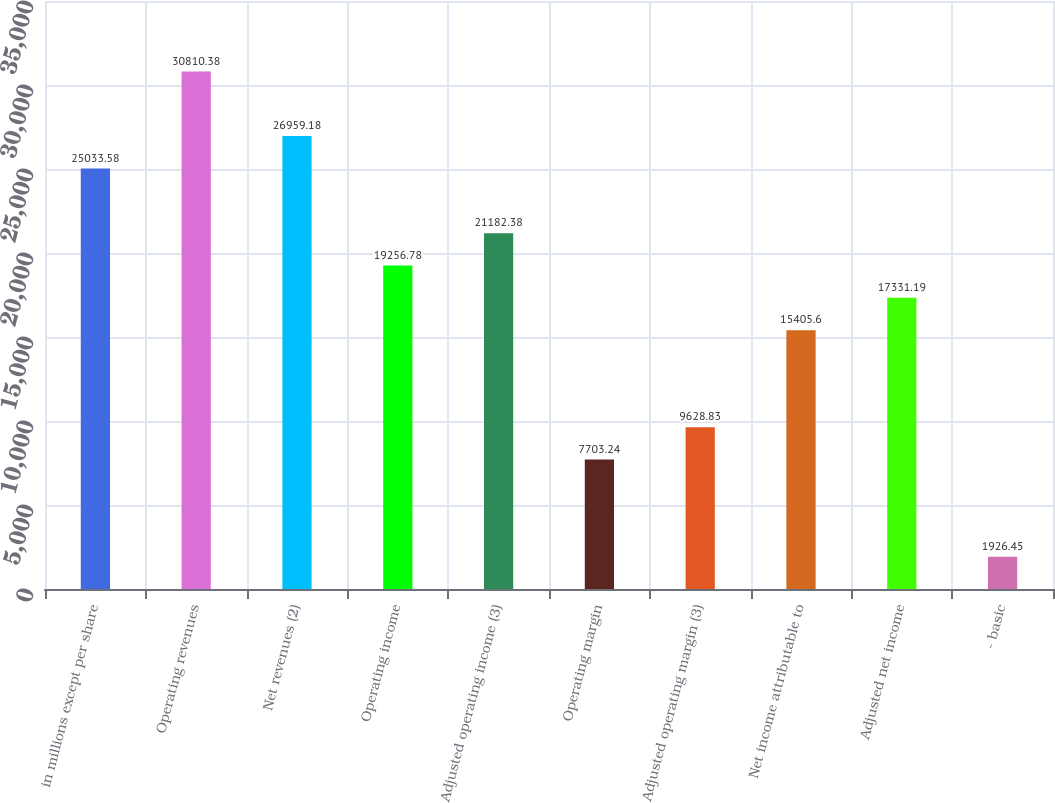Convert chart to OTSL. <chart><loc_0><loc_0><loc_500><loc_500><bar_chart><fcel>in millions except per share<fcel>Operating revenues<fcel>Net revenues (2)<fcel>Operating income<fcel>Adjusted operating income (3)<fcel>Operating margin<fcel>Adjusted operating margin (3)<fcel>Net income attributable to<fcel>Adjusted net income<fcel>- basic<nl><fcel>25033.6<fcel>30810.4<fcel>26959.2<fcel>19256.8<fcel>21182.4<fcel>7703.24<fcel>9628.83<fcel>15405.6<fcel>17331.2<fcel>1926.45<nl></chart> 